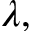Convert formula to latex. <formula><loc_0><loc_0><loc_500><loc_500>\lambda ,</formula> 